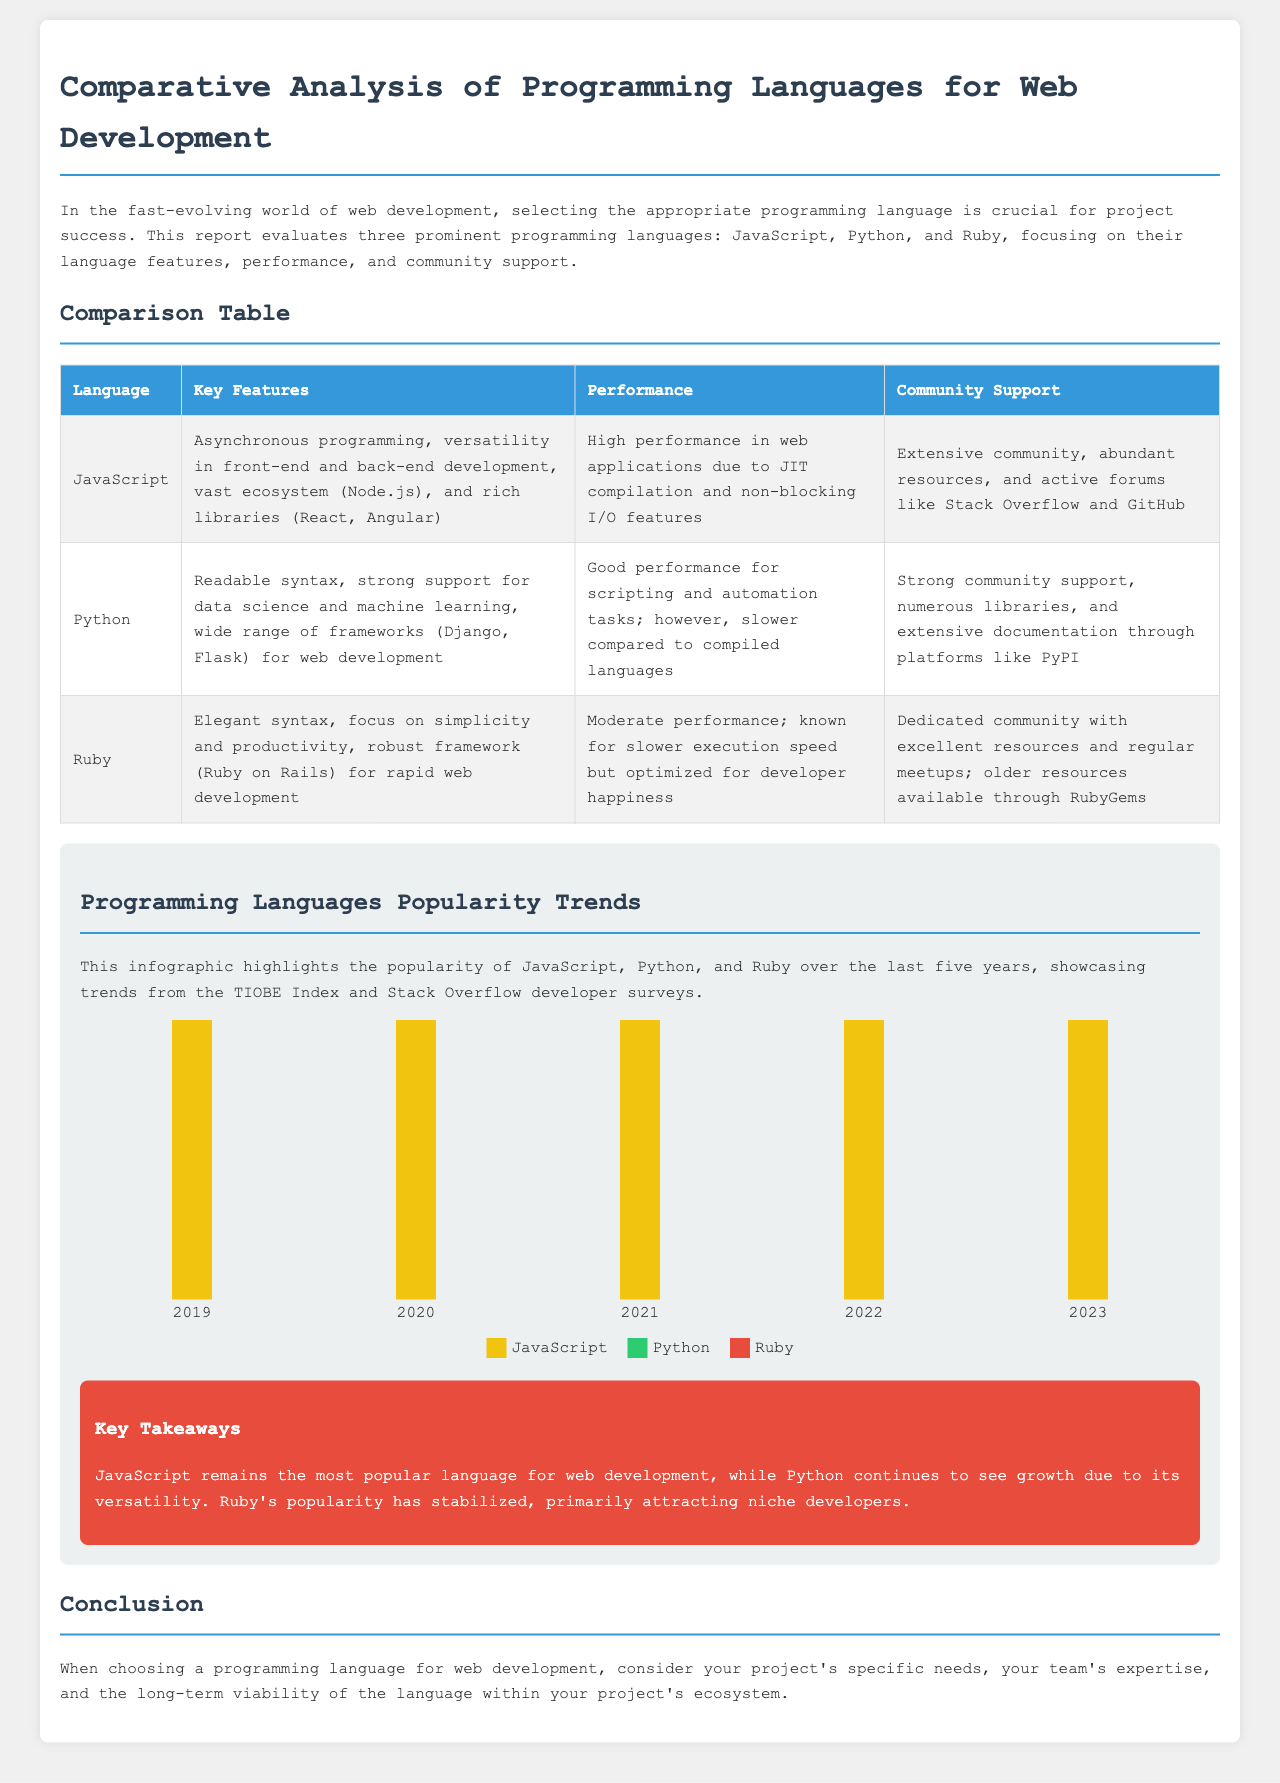What are the three programming languages evaluated in the report? The report evaluates three programming languages: JavaScript, Python, and Ruby.
Answer: JavaScript, Python, Ruby What is the key feature of Python? The key feature of Python, as mentioned in the document, is readable syntax, strong support for data science and machine learning.
Answer: Readable syntax What year did Python show a higher popularity trend than Ruby according to the infographic? The infographic indicates that in 2019, Python had a higher popularity than Ruby, reflecting data trends.
Answer: 2019 What is the community support for Ruby characterized as? The community support for Ruby is characterized as a dedicated community with excellent resources and regular meetups.
Answer: Dedicated community What is the performance of JavaScript described as? The performance of JavaScript is described as high performance in web applications due to its JIT compilation and non-blocking I/O features.
Answer: High performance In which year did Ruby's popularity attract 12 according to the data? According to the data, Ruby's popularity attracted a rating of 12 in the years 2021 and 2022.
Answer: 2021, 2022 Which programming language has a moderate performance and is known for slower execution speed? The programming language known for moderate performance and slower execution speed is Ruby.
Answer: Ruby Which programming language remains the most popular language for web development? The document states that JavaScript remains the most popular language for web development.
Answer: JavaScript What is the key takeaway about Python's growth? The key takeaway is that Python continues to see growth due to its versatility.
Answer: Python continues to see growth 